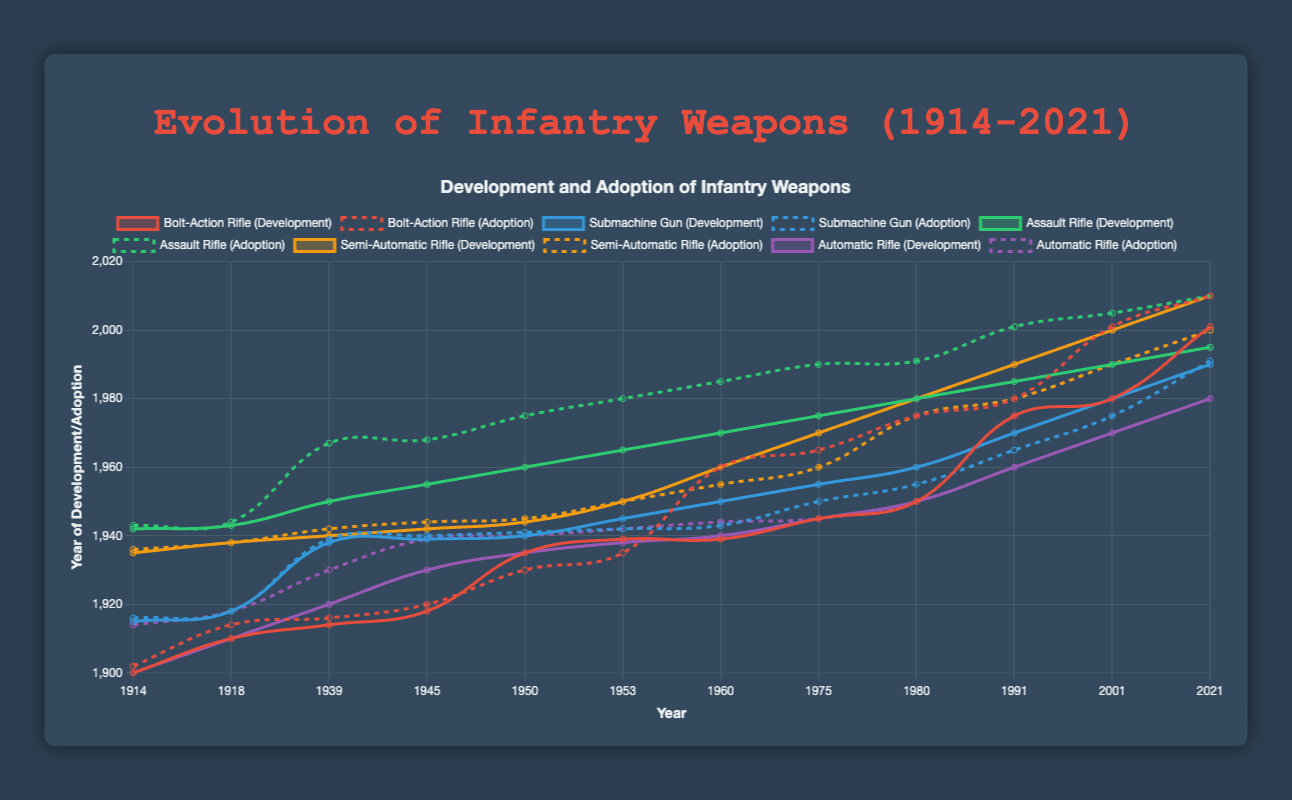Which weapon was adopted first, the Bolt-Action Rifle or the Submachine Gun? The Bolt-Action Rifle was adopted in 1902, whereas the Submachine Gun was adopted in 1916.
Answer: Bolt-Action Rifle What is the difference between the development year and adoption year of the first Submachine Gun? The Submachine Gun was developed in 1915 and adopted in 1916. The difference between these years is 1 year.
Answer: 1 year Which weapon had a longer development period before World War II, the Semi-Automatic Rifle or the Assault Rifle? The Semi-Automatic Rifle development started in 1935 and continued till 1944 (9 years), whereas the Assault Rifle development started in 1942 and continued till 1945 (3 years).
Answer: Semi-Automatic Rifle In which decade did the highest adoption rate occur for Bolt-Action Rifles? The highest adoption rate for Bolt-Action Rifles occurred in the 1910s with three adoptions in 1914, 1916, and 1920.
Answer: 1910s How many years after the first development of the Automatic Rifle was it adopted? The Automatic Rifle was developed in 1900 and adopted in 1914. Therefore, it was adopted 14 years after its first development.
Answer: 14 years Which weapon’s adoption year moved from the 1940s to the 1960s for major revisions? Compare the weapon's development period. The Assault Rifle's adoption moved from the 1940s to the 1960s (1967). The development period of the Assault Rifle was from 1942 (first) to 1965, compared to other weapons with multiple intervals of development like Semi-Automatic and Automatic.
Answer: Assault Rifle Did any weapon see an overlap in development and adoption periods? If so, which one? Yes, the Semi-Automatic Rifle saw an overlap in its development and adoption periods, specifically in the 1940s. Both development and adoption occurred between 1936-1944.
Answer: Semi-Automatic Rifle What are the commonalities in the development and adoption periods of the Automatic and Bolt-Action Rifles? Both weapons saw significant developments and adoptions during the early 20th century and World War I period. The Automatic Rifle was adopted in 1914, while the Bolt-Action Rifle had major adoptions in the 1910s and developments in the early 1900s and World War I period.
Answer: Early 20th century, World War I period 